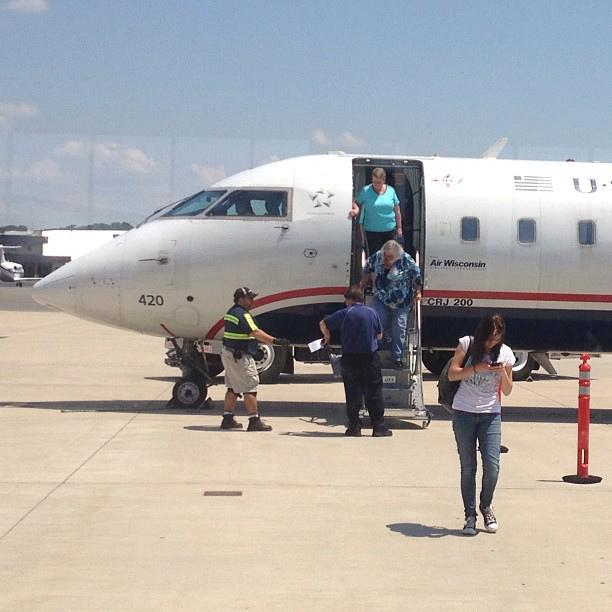What is the woman in the white shirt using in her hands? phone 